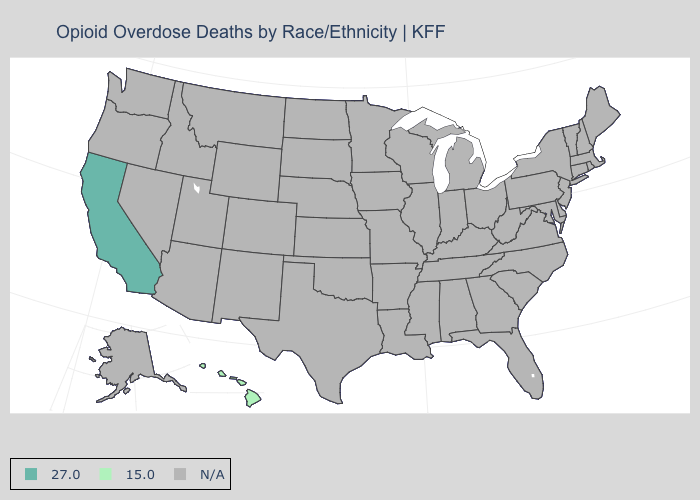Which states have the highest value in the USA?
Answer briefly. California. What is the value of Alabama?
Quick response, please. N/A. How many symbols are there in the legend?
Keep it brief. 3. Which states have the lowest value in the USA?
Write a very short answer. Hawaii. What is the highest value in the USA?
Give a very brief answer. 27.0. Does Hawaii have the highest value in the USA?
Answer briefly. No. Does the map have missing data?
Be succinct. Yes. What is the value of Missouri?
Answer briefly. N/A. Name the states that have a value in the range N/A?
Quick response, please. Alabama, Alaska, Arizona, Arkansas, Colorado, Connecticut, Delaware, Florida, Georgia, Idaho, Illinois, Indiana, Iowa, Kansas, Kentucky, Louisiana, Maine, Maryland, Massachusetts, Michigan, Minnesota, Mississippi, Missouri, Montana, Nebraska, Nevada, New Hampshire, New Jersey, New Mexico, New York, North Carolina, North Dakota, Ohio, Oklahoma, Oregon, Pennsylvania, Rhode Island, South Carolina, South Dakota, Tennessee, Texas, Utah, Vermont, Virginia, Washington, West Virginia, Wisconsin, Wyoming. What is the highest value in the USA?
Write a very short answer. 27.0. What is the value of Michigan?
Answer briefly. N/A. 